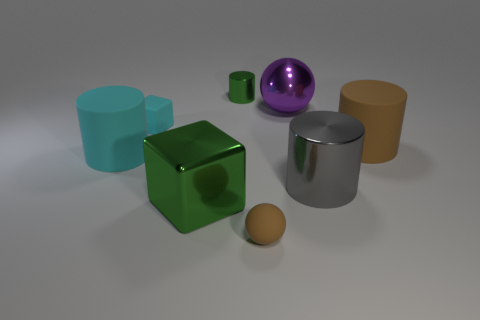There is a small matte thing in front of the small cyan matte cube; is it the same shape as the rubber thing left of the rubber cube?
Your answer should be very brief. No. What number of purple metal objects are in front of the large metallic sphere?
Keep it short and to the point. 0. Are there any brown cylinders that have the same material as the small sphere?
Your response must be concise. Yes. There is a purple ball that is the same size as the green cube; what is it made of?
Your response must be concise. Metal. Is the big block made of the same material as the tiny brown ball?
Your response must be concise. No. What number of objects are big metal spheres or large brown matte cylinders?
Your answer should be very brief. 2. What is the shape of the large brown object to the right of the large cyan cylinder?
Your response must be concise. Cylinder. What is the color of the other cylinder that is the same material as the brown cylinder?
Offer a terse response. Cyan. There is a cyan thing that is the same shape as the big gray shiny thing; what is its material?
Ensure brevity in your answer.  Rubber. There is a purple metallic thing; what shape is it?
Your answer should be compact. Sphere. 